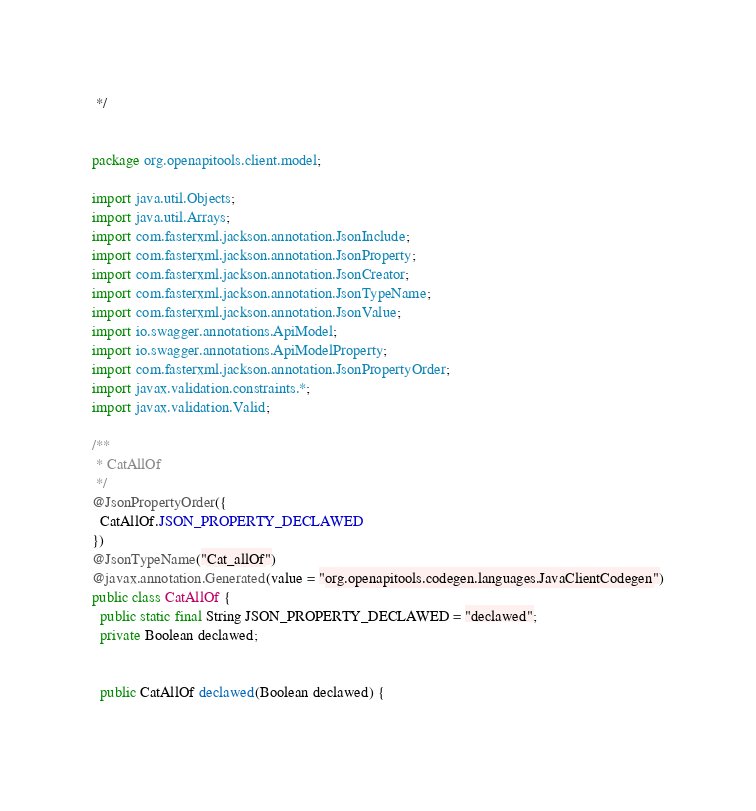Convert code to text. <code><loc_0><loc_0><loc_500><loc_500><_Java_> */


package org.openapitools.client.model;

import java.util.Objects;
import java.util.Arrays;
import com.fasterxml.jackson.annotation.JsonInclude;
import com.fasterxml.jackson.annotation.JsonProperty;
import com.fasterxml.jackson.annotation.JsonCreator;
import com.fasterxml.jackson.annotation.JsonTypeName;
import com.fasterxml.jackson.annotation.JsonValue;
import io.swagger.annotations.ApiModel;
import io.swagger.annotations.ApiModelProperty;
import com.fasterxml.jackson.annotation.JsonPropertyOrder;
import javax.validation.constraints.*;
import javax.validation.Valid;

/**
 * CatAllOf
 */
@JsonPropertyOrder({
  CatAllOf.JSON_PROPERTY_DECLAWED
})
@JsonTypeName("Cat_allOf")
@javax.annotation.Generated(value = "org.openapitools.codegen.languages.JavaClientCodegen")
public class CatAllOf {
  public static final String JSON_PROPERTY_DECLAWED = "declawed";
  private Boolean declawed;


  public CatAllOf declawed(Boolean declawed) {
    </code> 